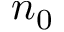<formula> <loc_0><loc_0><loc_500><loc_500>n _ { 0 }</formula> 